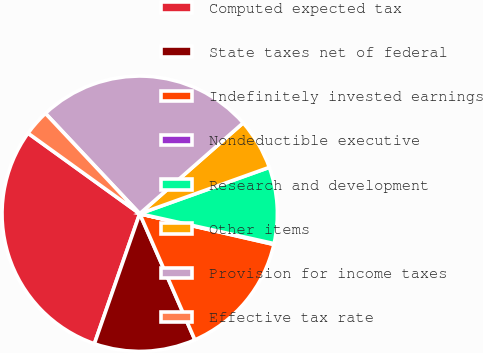Convert chart to OTSL. <chart><loc_0><loc_0><loc_500><loc_500><pie_chart><fcel>Computed expected tax<fcel>State taxes net of federal<fcel>Indefinitely invested earnings<fcel>Nondeductible executive<fcel>Research and development<fcel>Other items<fcel>Provision for income taxes<fcel>Effective tax rate<nl><fcel>29.6%<fcel>11.9%<fcel>14.85%<fcel>0.1%<fcel>8.95%<fcel>6.0%<fcel>25.53%<fcel>3.05%<nl></chart> 